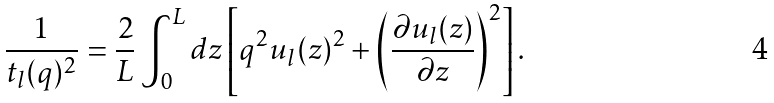Convert formula to latex. <formula><loc_0><loc_0><loc_500><loc_500>\frac { 1 } { t _ { l } ( q ) ^ { 2 } } = \frac { 2 } { L } \int _ { 0 } ^ { L } d z \left [ q ^ { 2 } u _ { l } ( z ) ^ { 2 } + \left ( \frac { \partial u _ { l } ( z ) } { \partial z } \right ) ^ { 2 } \right ] .</formula> 